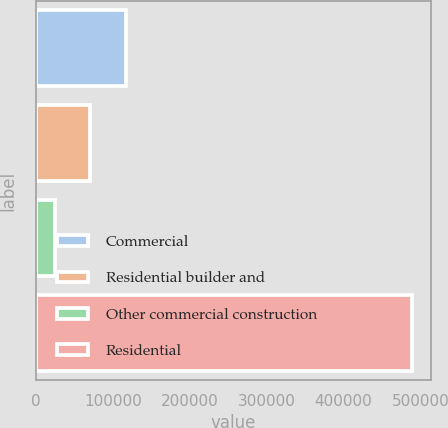Convert chart. <chart><loc_0><loc_0><loc_500><loc_500><bar_chart><fcel>Commercial<fcel>Residential builder and<fcel>Other commercial construction<fcel>Residential<nl><fcel>117340<fcel>70932.4<fcel>24525<fcel>488599<nl></chart> 